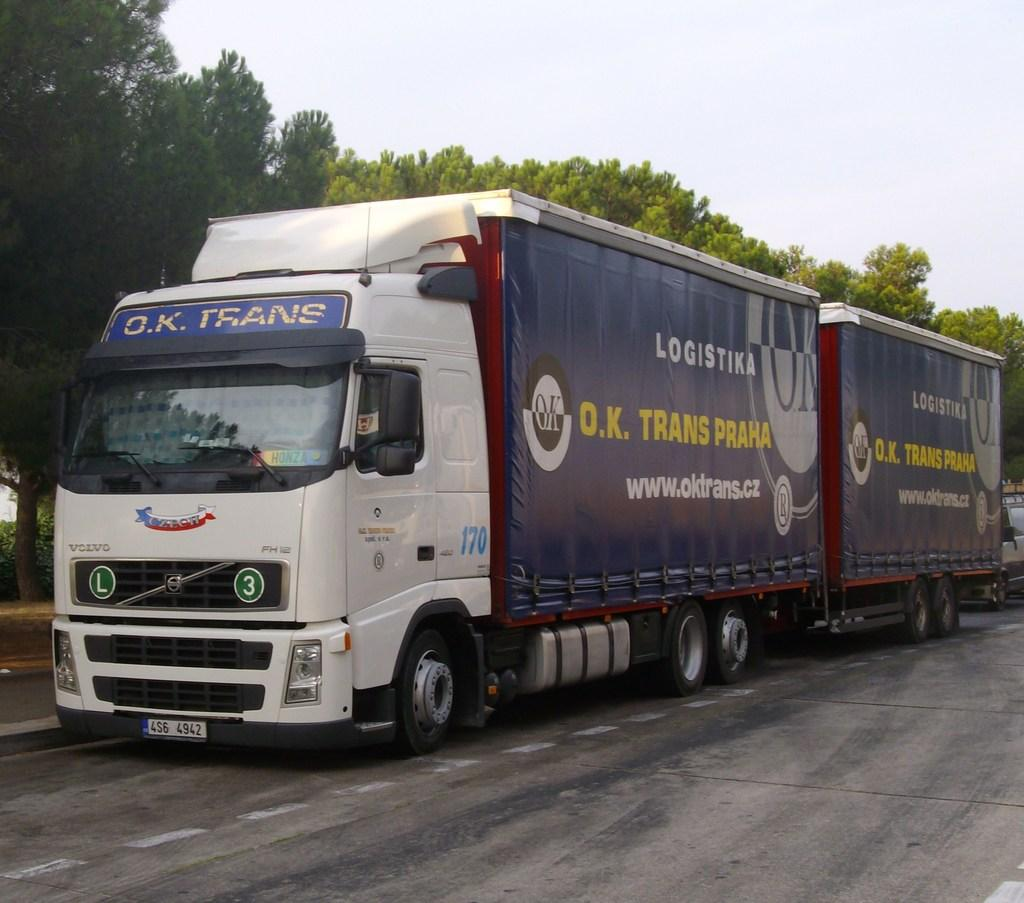What can be seen on the road in the image? There are vehicles on the road in the image. What type of natural elements are present in the image? There are trees and plants in the image. What part of the environment is visible in the background of the image? The sky is visible in the background of the image. What type of drug can be seen in the image? There is no drug present in the image. What kind of dress is being worn by the trees in the image? The trees in the image are not wearing any dresses, as they are natural elements and not people. 